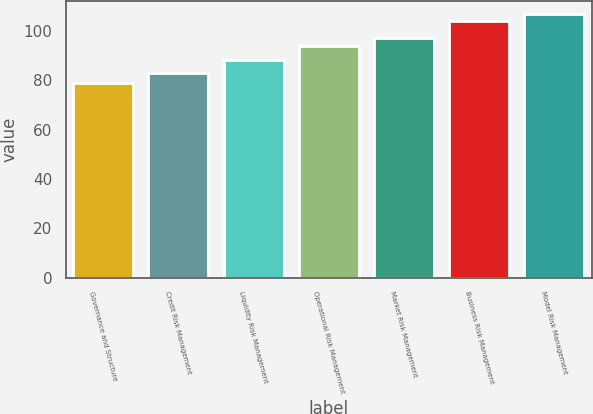<chart> <loc_0><loc_0><loc_500><loc_500><bar_chart><fcel>Governance and Structure<fcel>Credit Risk Management<fcel>Liquidity Risk Management<fcel>Operational Risk Management<fcel>Market Risk Management<fcel>Business Risk Management<fcel>Model Risk Management<nl><fcel>79<fcel>83<fcel>88<fcel>94<fcel>97<fcel>104<fcel>106.6<nl></chart> 